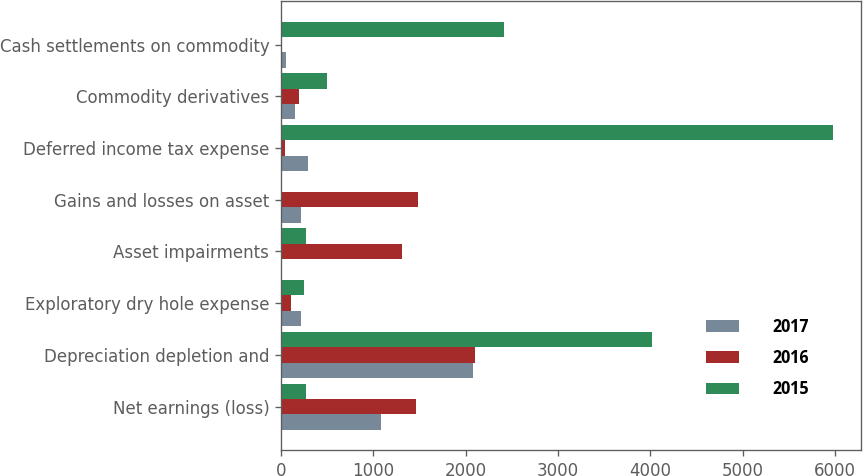Convert chart to OTSL. <chart><loc_0><loc_0><loc_500><loc_500><stacked_bar_chart><ecel><fcel>Net earnings (loss)<fcel>Depreciation depletion and<fcel>Exploratory dry hole expense<fcel>Asset impairments<fcel>Gains and losses on asset<fcel>Deferred income tax expense<fcel>Commodity derivatives<fcel>Cash settlements on commodity<nl><fcel>2017<fcel>1078<fcel>2074<fcel>219<fcel>17<fcel>217<fcel>294<fcel>157<fcel>53<nl><fcel>2016<fcel>1458<fcel>2096<fcel>113<fcel>1310<fcel>1483<fcel>41<fcel>201<fcel>1<nl><fcel>2015<fcel>271<fcel>4022<fcel>248<fcel>271<fcel>7<fcel>5976<fcel>503<fcel>2416<nl></chart> 